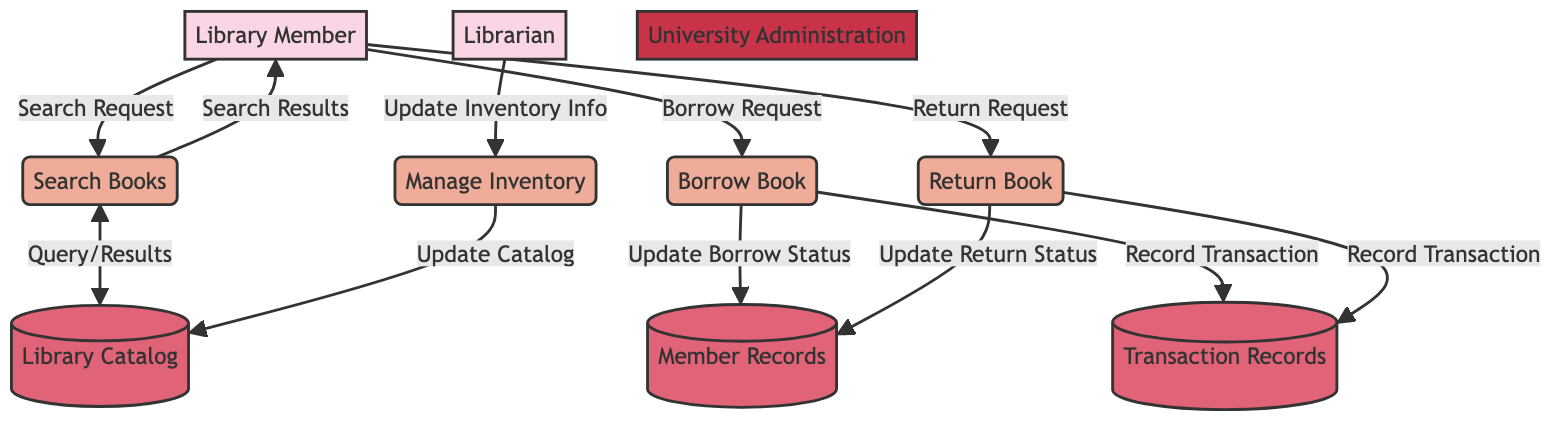What is the main purpose of the "Search Books" process? The "Search Books" process is utilized by a Library Member to search for books within the Library Catalog. This action begins with the Library Member submitting a search request, which leads to a query being made to the Library Catalog.
Answer: To search for books How many data stores are present in the diagram? The diagram features two data stores: "Member Records" and "Transaction Records." Each serves distinct purposes in storing relevant information regarding library members and transactions.
Answer: Two What data flows from "Library Member" to "Borrow Book"? The data flow from the Library Member to the Borrow Book process consists of a "Borrow Request." This indicates the member's intention to borrow a specific book from the library.
Answer: Borrow Request Who updates the inventory information? The inventory information is updated by the Librarian. This occurs through the "Manage Inventory" process, where the Librarian checks and updates the list of available books.
Answer: Librarian What triggers the "Record Transaction" action? The "Record Transaction" action is triggered twice: once during the "Borrow Book" process and once during the "Return Book" process. This indicates that transactions must be recorded for both borrowing and returning actions conducted by library members.
Answer: Borrow Book and Return Book What is updated in the "Member Records" datastore when a book is returned? When a book is returned, the "Update Return Status" operation updates the "Member Records" datastore to reflect the status of the returned book. This process ensures that the member's borrowing status is accurately recorded.
Answer: Update Return Status 